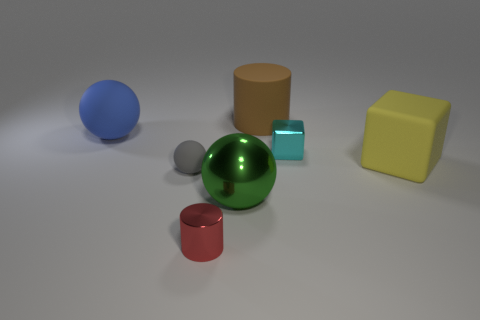Add 3 green rubber cylinders. How many objects exist? 10 Subtract all small spheres. How many spheres are left? 2 Subtract all blocks. How many objects are left? 5 Subtract 1 cylinders. How many cylinders are left? 1 Subtract all red spheres. Subtract all blue cylinders. How many spheres are left? 3 Subtract all yellow spheres. How many cyan cylinders are left? 0 Subtract all tiny purple metal spheres. Subtract all small cyan objects. How many objects are left? 6 Add 6 large green shiny balls. How many large green shiny balls are left? 7 Add 7 matte blocks. How many matte blocks exist? 8 Subtract all brown cylinders. How many cylinders are left? 1 